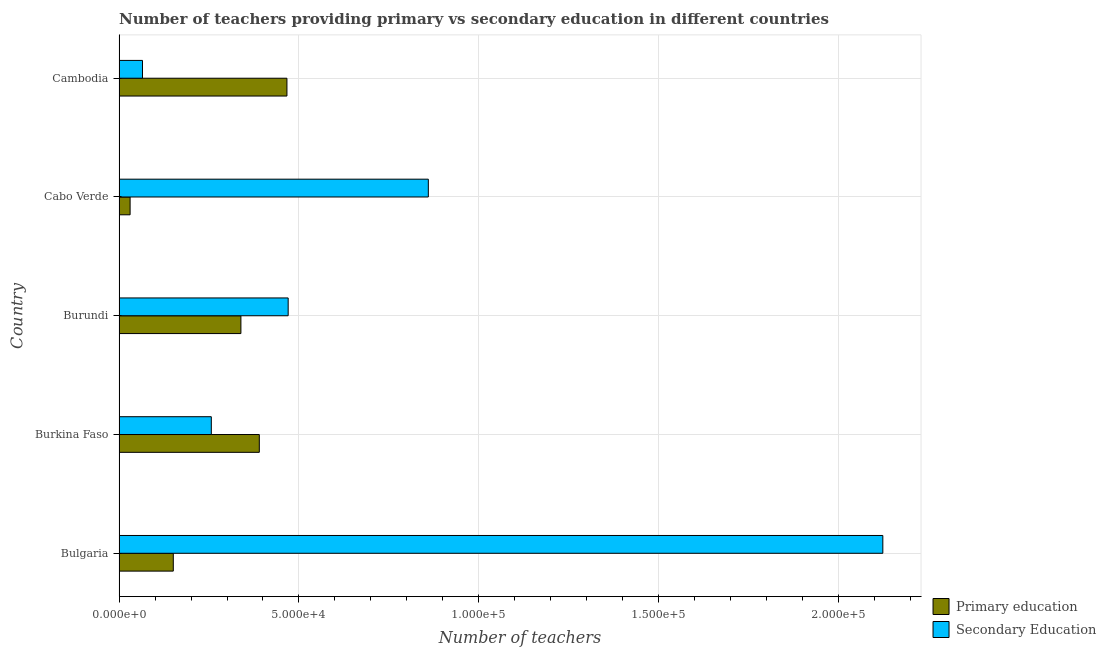Are the number of bars per tick equal to the number of legend labels?
Keep it short and to the point. Yes. Are the number of bars on each tick of the Y-axis equal?
Your answer should be very brief. Yes. What is the label of the 3rd group of bars from the top?
Provide a short and direct response. Burundi. What is the number of secondary teachers in Cambodia?
Make the answer very short. 6512. Across all countries, what is the maximum number of secondary teachers?
Make the answer very short. 2.12e+05. Across all countries, what is the minimum number of primary teachers?
Make the answer very short. 3072. In which country was the number of secondary teachers maximum?
Offer a terse response. Bulgaria. In which country was the number of primary teachers minimum?
Provide a short and direct response. Cabo Verde. What is the total number of secondary teachers in the graph?
Your response must be concise. 3.77e+05. What is the difference between the number of secondary teachers in Burundi and that in Cambodia?
Provide a succinct answer. 4.05e+04. What is the difference between the number of secondary teachers in Bulgaria and the number of primary teachers in Burkina Faso?
Give a very brief answer. 1.73e+05. What is the average number of secondary teachers per country?
Keep it short and to the point. 7.55e+04. What is the difference between the number of secondary teachers and number of primary teachers in Burundi?
Your answer should be compact. 1.31e+04. What is the ratio of the number of primary teachers in Bulgaria to that in Burkina Faso?
Your answer should be very brief. 0.39. Is the number of primary teachers in Bulgaria less than that in Burundi?
Make the answer very short. Yes. What is the difference between the highest and the second highest number of primary teachers?
Provide a succinct answer. 7675. What is the difference between the highest and the lowest number of primary teachers?
Provide a succinct answer. 4.36e+04. In how many countries, is the number of secondary teachers greater than the average number of secondary teachers taken over all countries?
Your answer should be very brief. 2. Is the sum of the number of primary teachers in Bulgaria and Cambodia greater than the maximum number of secondary teachers across all countries?
Provide a short and direct response. No. What does the 1st bar from the bottom in Cambodia represents?
Your response must be concise. Primary education. Are all the bars in the graph horizontal?
Ensure brevity in your answer.  Yes. What is the difference between two consecutive major ticks on the X-axis?
Give a very brief answer. 5.00e+04. How are the legend labels stacked?
Make the answer very short. Vertical. What is the title of the graph?
Ensure brevity in your answer.  Number of teachers providing primary vs secondary education in different countries. What is the label or title of the X-axis?
Offer a very short reply. Number of teachers. What is the Number of teachers in Primary education in Bulgaria?
Provide a short and direct response. 1.51e+04. What is the Number of teachers of Secondary Education in Bulgaria?
Offer a very short reply. 2.12e+05. What is the Number of teachers of Primary education in Burkina Faso?
Your answer should be very brief. 3.90e+04. What is the Number of teachers in Secondary Education in Burkina Faso?
Ensure brevity in your answer.  2.56e+04. What is the Number of teachers in Primary education in Burundi?
Give a very brief answer. 3.39e+04. What is the Number of teachers in Secondary Education in Burundi?
Your answer should be compact. 4.70e+04. What is the Number of teachers of Primary education in Cabo Verde?
Provide a short and direct response. 3072. What is the Number of teachers of Secondary Education in Cabo Verde?
Make the answer very short. 8.60e+04. What is the Number of teachers in Primary education in Cambodia?
Provide a succinct answer. 4.67e+04. What is the Number of teachers in Secondary Education in Cambodia?
Provide a short and direct response. 6512. Across all countries, what is the maximum Number of teachers of Primary education?
Make the answer very short. 4.67e+04. Across all countries, what is the maximum Number of teachers of Secondary Education?
Your answer should be compact. 2.12e+05. Across all countries, what is the minimum Number of teachers in Primary education?
Ensure brevity in your answer.  3072. Across all countries, what is the minimum Number of teachers in Secondary Education?
Offer a very short reply. 6512. What is the total Number of teachers of Primary education in the graph?
Offer a terse response. 1.38e+05. What is the total Number of teachers of Secondary Education in the graph?
Give a very brief answer. 3.77e+05. What is the difference between the Number of teachers of Primary education in Bulgaria and that in Burkina Faso?
Provide a succinct answer. -2.39e+04. What is the difference between the Number of teachers in Secondary Education in Bulgaria and that in Burkina Faso?
Keep it short and to the point. 1.87e+05. What is the difference between the Number of teachers in Primary education in Bulgaria and that in Burundi?
Offer a very short reply. -1.88e+04. What is the difference between the Number of teachers of Secondary Education in Bulgaria and that in Burundi?
Provide a short and direct response. 1.65e+05. What is the difference between the Number of teachers in Primary education in Bulgaria and that in Cabo Verde?
Your answer should be compact. 1.20e+04. What is the difference between the Number of teachers of Secondary Education in Bulgaria and that in Cabo Verde?
Keep it short and to the point. 1.26e+05. What is the difference between the Number of teachers in Primary education in Bulgaria and that in Cambodia?
Your answer should be very brief. -3.16e+04. What is the difference between the Number of teachers in Secondary Education in Bulgaria and that in Cambodia?
Offer a terse response. 2.06e+05. What is the difference between the Number of teachers of Primary education in Burkina Faso and that in Burundi?
Your answer should be very brief. 5116. What is the difference between the Number of teachers of Secondary Education in Burkina Faso and that in Burundi?
Provide a succinct answer. -2.14e+04. What is the difference between the Number of teachers in Primary education in Burkina Faso and that in Cabo Verde?
Offer a very short reply. 3.59e+04. What is the difference between the Number of teachers in Secondary Education in Burkina Faso and that in Cabo Verde?
Offer a terse response. -6.03e+04. What is the difference between the Number of teachers in Primary education in Burkina Faso and that in Cambodia?
Make the answer very short. -7675. What is the difference between the Number of teachers in Secondary Education in Burkina Faso and that in Cambodia?
Give a very brief answer. 1.91e+04. What is the difference between the Number of teachers in Primary education in Burundi and that in Cabo Verde?
Make the answer very short. 3.08e+04. What is the difference between the Number of teachers in Secondary Education in Burundi and that in Cabo Verde?
Your response must be concise. -3.90e+04. What is the difference between the Number of teachers of Primary education in Burundi and that in Cambodia?
Your response must be concise. -1.28e+04. What is the difference between the Number of teachers in Secondary Education in Burundi and that in Cambodia?
Give a very brief answer. 4.05e+04. What is the difference between the Number of teachers in Primary education in Cabo Verde and that in Cambodia?
Your answer should be very brief. -4.36e+04. What is the difference between the Number of teachers in Secondary Education in Cabo Verde and that in Cambodia?
Provide a succinct answer. 7.94e+04. What is the difference between the Number of teachers in Primary education in Bulgaria and the Number of teachers in Secondary Education in Burkina Faso?
Your answer should be very brief. -1.06e+04. What is the difference between the Number of teachers of Primary education in Bulgaria and the Number of teachers of Secondary Education in Burundi?
Your answer should be compact. -3.19e+04. What is the difference between the Number of teachers in Primary education in Bulgaria and the Number of teachers in Secondary Education in Cabo Verde?
Provide a succinct answer. -7.09e+04. What is the difference between the Number of teachers of Primary education in Bulgaria and the Number of teachers of Secondary Education in Cambodia?
Provide a succinct answer. 8563. What is the difference between the Number of teachers of Primary education in Burkina Faso and the Number of teachers of Secondary Education in Burundi?
Offer a terse response. -8018. What is the difference between the Number of teachers of Primary education in Burkina Faso and the Number of teachers of Secondary Education in Cabo Verde?
Ensure brevity in your answer.  -4.70e+04. What is the difference between the Number of teachers of Primary education in Burkina Faso and the Number of teachers of Secondary Education in Cambodia?
Offer a terse response. 3.25e+04. What is the difference between the Number of teachers of Primary education in Burundi and the Number of teachers of Secondary Education in Cabo Verde?
Offer a very short reply. -5.21e+04. What is the difference between the Number of teachers of Primary education in Burundi and the Number of teachers of Secondary Education in Cambodia?
Keep it short and to the point. 2.74e+04. What is the difference between the Number of teachers of Primary education in Cabo Verde and the Number of teachers of Secondary Education in Cambodia?
Ensure brevity in your answer.  -3440. What is the average Number of teachers in Primary education per country?
Your response must be concise. 2.75e+04. What is the average Number of teachers in Secondary Education per country?
Provide a succinct answer. 7.55e+04. What is the difference between the Number of teachers of Primary education and Number of teachers of Secondary Education in Bulgaria?
Keep it short and to the point. -1.97e+05. What is the difference between the Number of teachers in Primary education and Number of teachers in Secondary Education in Burkina Faso?
Make the answer very short. 1.33e+04. What is the difference between the Number of teachers of Primary education and Number of teachers of Secondary Education in Burundi?
Keep it short and to the point. -1.31e+04. What is the difference between the Number of teachers of Primary education and Number of teachers of Secondary Education in Cabo Verde?
Your answer should be compact. -8.29e+04. What is the difference between the Number of teachers of Primary education and Number of teachers of Secondary Education in Cambodia?
Make the answer very short. 4.01e+04. What is the ratio of the Number of teachers of Primary education in Bulgaria to that in Burkina Faso?
Give a very brief answer. 0.39. What is the ratio of the Number of teachers in Secondary Education in Bulgaria to that in Burkina Faso?
Your response must be concise. 8.28. What is the ratio of the Number of teachers in Primary education in Bulgaria to that in Burundi?
Make the answer very short. 0.45. What is the ratio of the Number of teachers in Secondary Education in Bulgaria to that in Burundi?
Offer a terse response. 4.52. What is the ratio of the Number of teachers in Primary education in Bulgaria to that in Cabo Verde?
Keep it short and to the point. 4.91. What is the ratio of the Number of teachers of Secondary Education in Bulgaria to that in Cabo Verde?
Provide a short and direct response. 2.47. What is the ratio of the Number of teachers in Primary education in Bulgaria to that in Cambodia?
Offer a terse response. 0.32. What is the ratio of the Number of teachers of Secondary Education in Bulgaria to that in Cambodia?
Keep it short and to the point. 32.6. What is the ratio of the Number of teachers of Primary education in Burkina Faso to that in Burundi?
Give a very brief answer. 1.15. What is the ratio of the Number of teachers of Secondary Education in Burkina Faso to that in Burundi?
Your answer should be very brief. 0.55. What is the ratio of the Number of teachers of Primary education in Burkina Faso to that in Cabo Verde?
Keep it short and to the point. 12.69. What is the ratio of the Number of teachers of Secondary Education in Burkina Faso to that in Cabo Verde?
Provide a succinct answer. 0.3. What is the ratio of the Number of teachers in Primary education in Burkina Faso to that in Cambodia?
Your answer should be compact. 0.84. What is the ratio of the Number of teachers of Secondary Education in Burkina Faso to that in Cambodia?
Your answer should be very brief. 3.94. What is the ratio of the Number of teachers in Primary education in Burundi to that in Cabo Verde?
Offer a very short reply. 11.02. What is the ratio of the Number of teachers in Secondary Education in Burundi to that in Cabo Verde?
Keep it short and to the point. 0.55. What is the ratio of the Number of teachers in Primary education in Burundi to that in Cambodia?
Your answer should be compact. 0.73. What is the ratio of the Number of teachers in Secondary Education in Burundi to that in Cambodia?
Your response must be concise. 7.22. What is the ratio of the Number of teachers in Primary education in Cabo Verde to that in Cambodia?
Offer a terse response. 0.07. What is the ratio of the Number of teachers in Secondary Education in Cabo Verde to that in Cambodia?
Provide a short and direct response. 13.2. What is the difference between the highest and the second highest Number of teachers in Primary education?
Give a very brief answer. 7675. What is the difference between the highest and the second highest Number of teachers of Secondary Education?
Offer a very short reply. 1.26e+05. What is the difference between the highest and the lowest Number of teachers in Primary education?
Your answer should be compact. 4.36e+04. What is the difference between the highest and the lowest Number of teachers in Secondary Education?
Your response must be concise. 2.06e+05. 